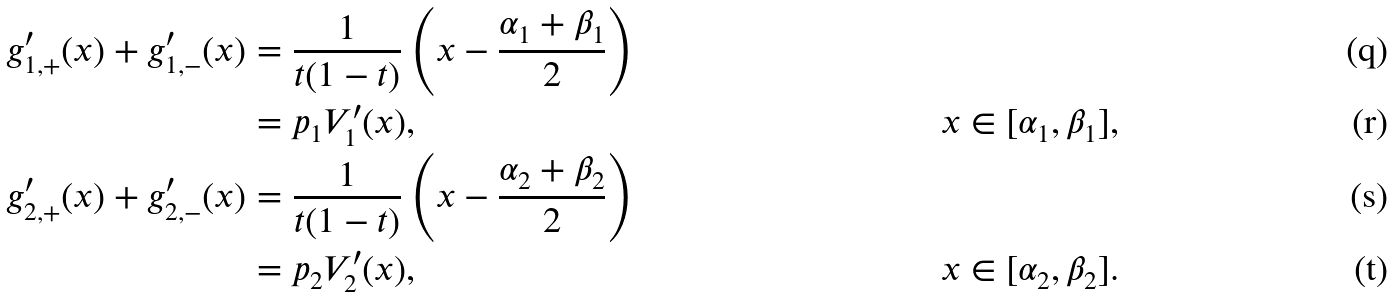Convert formula to latex. <formula><loc_0><loc_0><loc_500><loc_500>g _ { 1 , + } ^ { \prime } ( x ) + g _ { 1 , - } ^ { \prime } ( x ) & = \frac { 1 } { t ( 1 - t ) } \left ( x - \frac { \alpha _ { 1 } + \beta _ { 1 } } { 2 } \right ) \\ & = p _ { 1 } V _ { 1 } ^ { \prime } ( x ) , & \quad x \in [ \alpha _ { 1 } , \beta _ { 1 } ] , \\ g _ { 2 , + } ^ { \prime } ( x ) + g _ { 2 , - } ^ { \prime } ( x ) & = \frac { 1 } { t ( 1 - t ) } \left ( x - \frac { \alpha _ { 2 } + \beta _ { 2 } } { 2 } \right ) \\ & = p _ { 2 } V _ { 2 } ^ { \prime } ( x ) , & \quad x \in [ \alpha _ { 2 } , \beta _ { 2 } ] .</formula> 